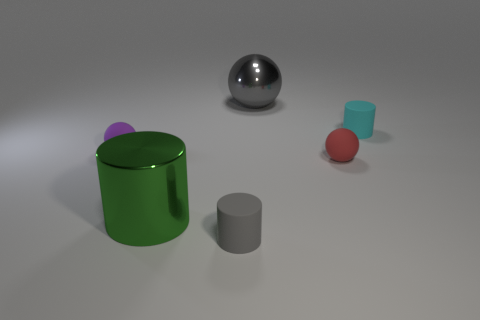Add 1 gray shiny cylinders. How many objects exist? 7 Subtract all tiny purple objects. Subtract all rubber spheres. How many objects are left? 3 Add 3 gray spheres. How many gray spheres are left? 4 Add 1 gray matte objects. How many gray matte objects exist? 2 Subtract 0 blue balls. How many objects are left? 6 